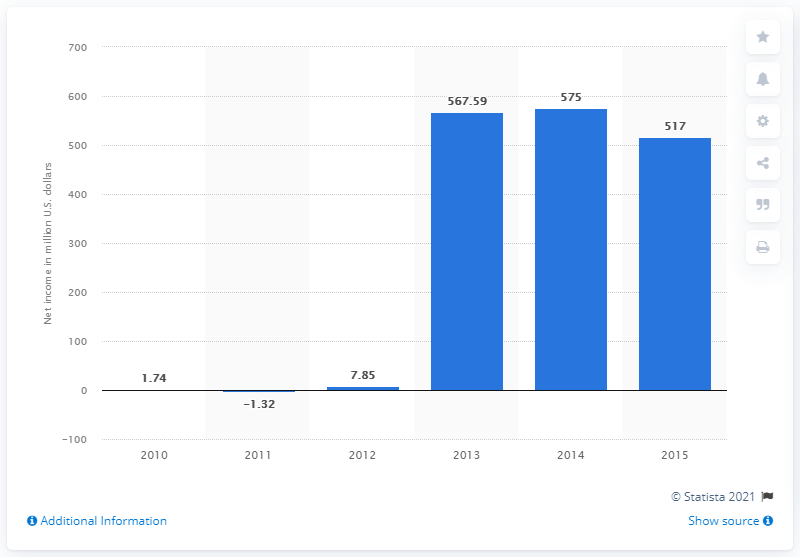Mention a couple of crucial points in this snapshot. In 2015, the net income of King.com was 517. 